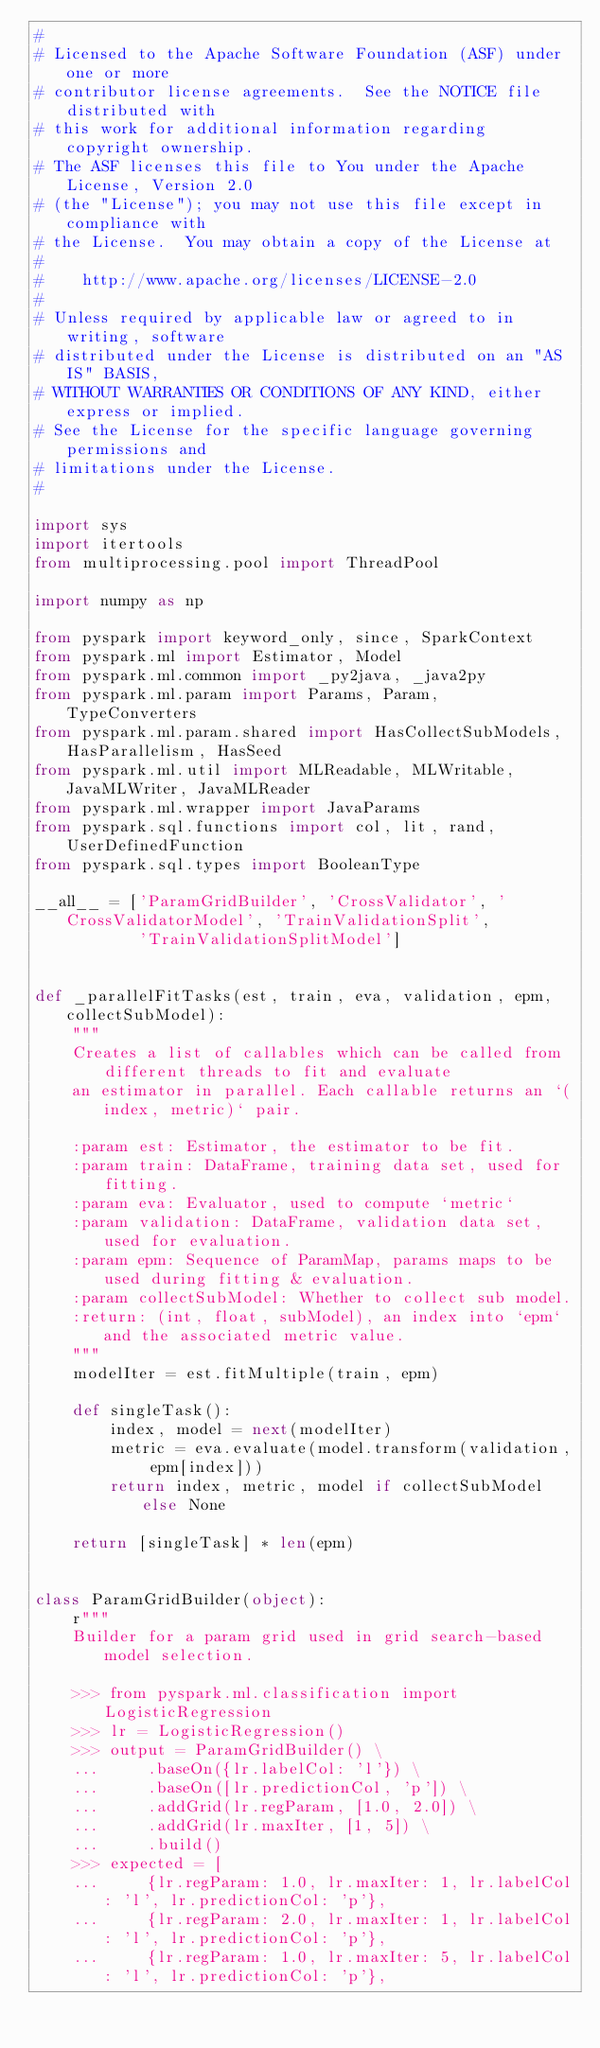Convert code to text. <code><loc_0><loc_0><loc_500><loc_500><_Python_>#
# Licensed to the Apache Software Foundation (ASF) under one or more
# contributor license agreements.  See the NOTICE file distributed with
# this work for additional information regarding copyright ownership.
# The ASF licenses this file to You under the Apache License, Version 2.0
# (the "License"); you may not use this file except in compliance with
# the License.  You may obtain a copy of the License at
#
#    http://www.apache.org/licenses/LICENSE-2.0
#
# Unless required by applicable law or agreed to in writing, software
# distributed under the License is distributed on an "AS IS" BASIS,
# WITHOUT WARRANTIES OR CONDITIONS OF ANY KIND, either express or implied.
# See the License for the specific language governing permissions and
# limitations under the License.
#

import sys
import itertools
from multiprocessing.pool import ThreadPool

import numpy as np

from pyspark import keyword_only, since, SparkContext
from pyspark.ml import Estimator, Model
from pyspark.ml.common import _py2java, _java2py
from pyspark.ml.param import Params, Param, TypeConverters
from pyspark.ml.param.shared import HasCollectSubModels, HasParallelism, HasSeed
from pyspark.ml.util import MLReadable, MLWritable, JavaMLWriter, JavaMLReader
from pyspark.ml.wrapper import JavaParams
from pyspark.sql.functions import col, lit, rand, UserDefinedFunction
from pyspark.sql.types import BooleanType

__all__ = ['ParamGridBuilder', 'CrossValidator', 'CrossValidatorModel', 'TrainValidationSplit',
           'TrainValidationSplitModel']


def _parallelFitTasks(est, train, eva, validation, epm, collectSubModel):
    """
    Creates a list of callables which can be called from different threads to fit and evaluate
    an estimator in parallel. Each callable returns an `(index, metric)` pair.

    :param est: Estimator, the estimator to be fit.
    :param train: DataFrame, training data set, used for fitting.
    :param eva: Evaluator, used to compute `metric`
    :param validation: DataFrame, validation data set, used for evaluation.
    :param epm: Sequence of ParamMap, params maps to be used during fitting & evaluation.
    :param collectSubModel: Whether to collect sub model.
    :return: (int, float, subModel), an index into `epm` and the associated metric value.
    """
    modelIter = est.fitMultiple(train, epm)

    def singleTask():
        index, model = next(modelIter)
        metric = eva.evaluate(model.transform(validation, epm[index]))
        return index, metric, model if collectSubModel else None

    return [singleTask] * len(epm)


class ParamGridBuilder(object):
    r"""
    Builder for a param grid used in grid search-based model selection.

    >>> from pyspark.ml.classification import LogisticRegression
    >>> lr = LogisticRegression()
    >>> output = ParamGridBuilder() \
    ...     .baseOn({lr.labelCol: 'l'}) \
    ...     .baseOn([lr.predictionCol, 'p']) \
    ...     .addGrid(lr.regParam, [1.0, 2.0]) \
    ...     .addGrid(lr.maxIter, [1, 5]) \
    ...     .build()
    >>> expected = [
    ...     {lr.regParam: 1.0, lr.maxIter: 1, lr.labelCol: 'l', lr.predictionCol: 'p'},
    ...     {lr.regParam: 2.0, lr.maxIter: 1, lr.labelCol: 'l', lr.predictionCol: 'p'},
    ...     {lr.regParam: 1.0, lr.maxIter: 5, lr.labelCol: 'l', lr.predictionCol: 'p'},</code> 